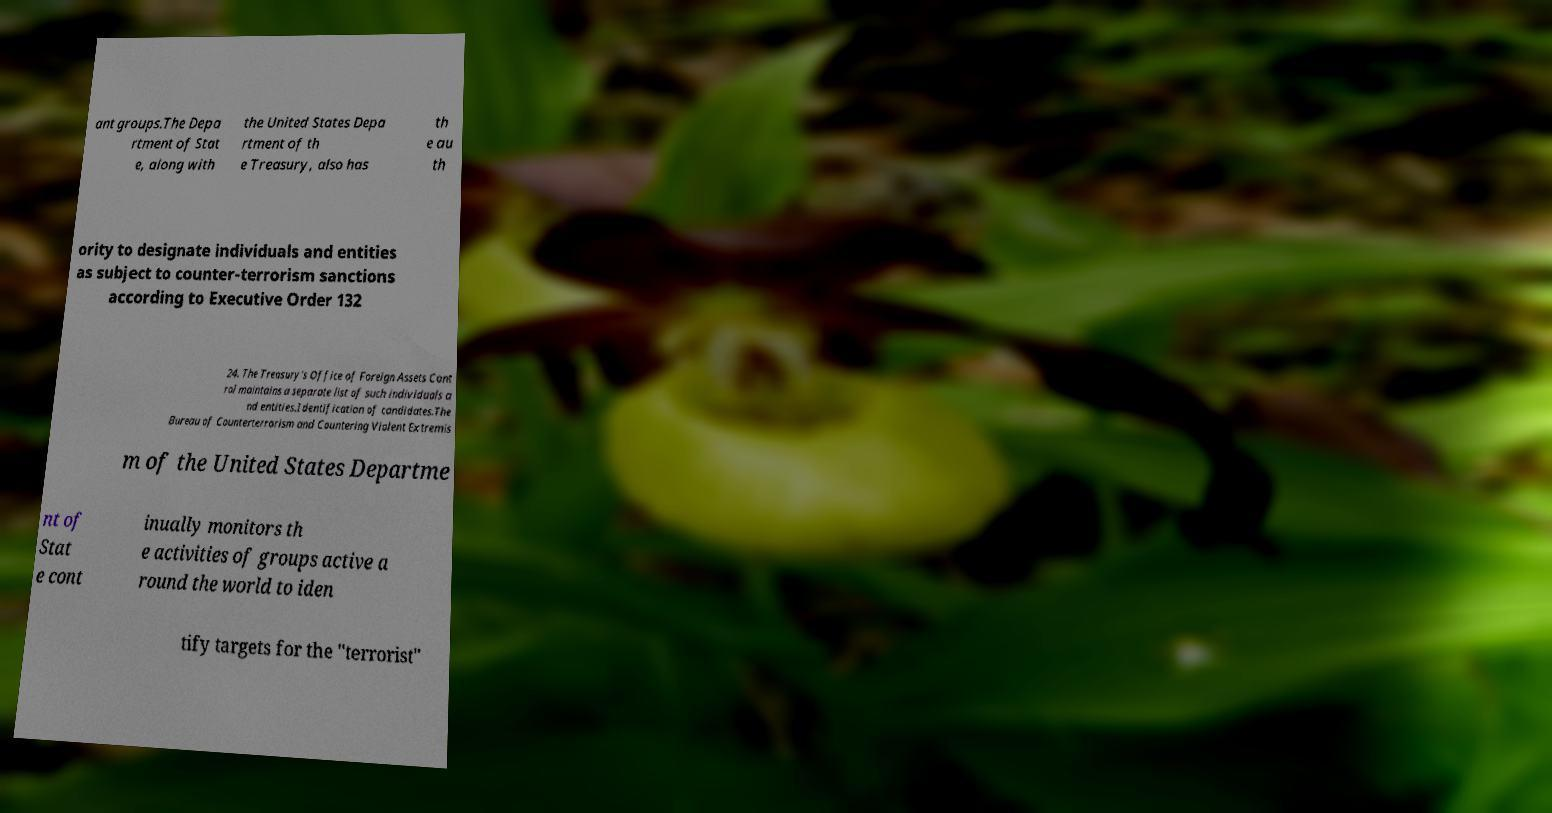What messages or text are displayed in this image? I need them in a readable, typed format. ant groups.The Depa rtment of Stat e, along with the United States Depa rtment of th e Treasury, also has th e au th ority to designate individuals and entities as subject to counter-terrorism sanctions according to Executive Order 132 24. The Treasury's Office of Foreign Assets Cont rol maintains a separate list of such individuals a nd entities.Identification of candidates.The Bureau of Counterterrorism and Countering Violent Extremis m of the United States Departme nt of Stat e cont inually monitors th e activities of groups active a round the world to iden tify targets for the "terrorist" 